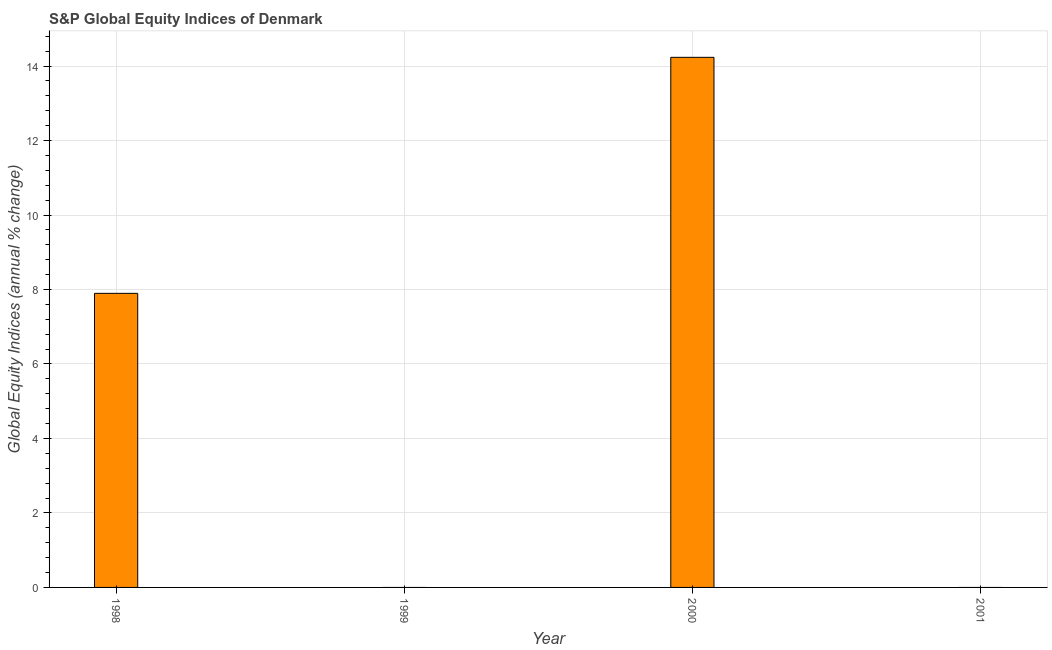What is the title of the graph?
Make the answer very short. S&P Global Equity Indices of Denmark. What is the label or title of the Y-axis?
Make the answer very short. Global Equity Indices (annual % change). What is the s&p global equity indices in 1999?
Provide a short and direct response. 0. Across all years, what is the maximum s&p global equity indices?
Your answer should be compact. 14.23. In which year was the s&p global equity indices maximum?
Your answer should be compact. 2000. What is the sum of the s&p global equity indices?
Provide a short and direct response. 22.13. What is the difference between the s&p global equity indices in 1998 and 2000?
Your answer should be compact. -6.34. What is the average s&p global equity indices per year?
Provide a succinct answer. 5.53. What is the median s&p global equity indices?
Make the answer very short. 3.95. What is the ratio of the s&p global equity indices in 1998 to that in 2000?
Your answer should be compact. 0.56. Is the s&p global equity indices in 1998 less than that in 2000?
Provide a short and direct response. Yes. Is the difference between the s&p global equity indices in 1998 and 2000 greater than the difference between any two years?
Your response must be concise. No. What is the difference between the highest and the lowest s&p global equity indices?
Ensure brevity in your answer.  14.23. How many bars are there?
Provide a succinct answer. 2. What is the difference between two consecutive major ticks on the Y-axis?
Your response must be concise. 2. Are the values on the major ticks of Y-axis written in scientific E-notation?
Ensure brevity in your answer.  No. What is the Global Equity Indices (annual % change) of 1998?
Your response must be concise. 7.9. What is the Global Equity Indices (annual % change) of 2000?
Offer a terse response. 14.23. What is the difference between the Global Equity Indices (annual % change) in 1998 and 2000?
Give a very brief answer. -6.34. What is the ratio of the Global Equity Indices (annual % change) in 1998 to that in 2000?
Offer a very short reply. 0.56. 